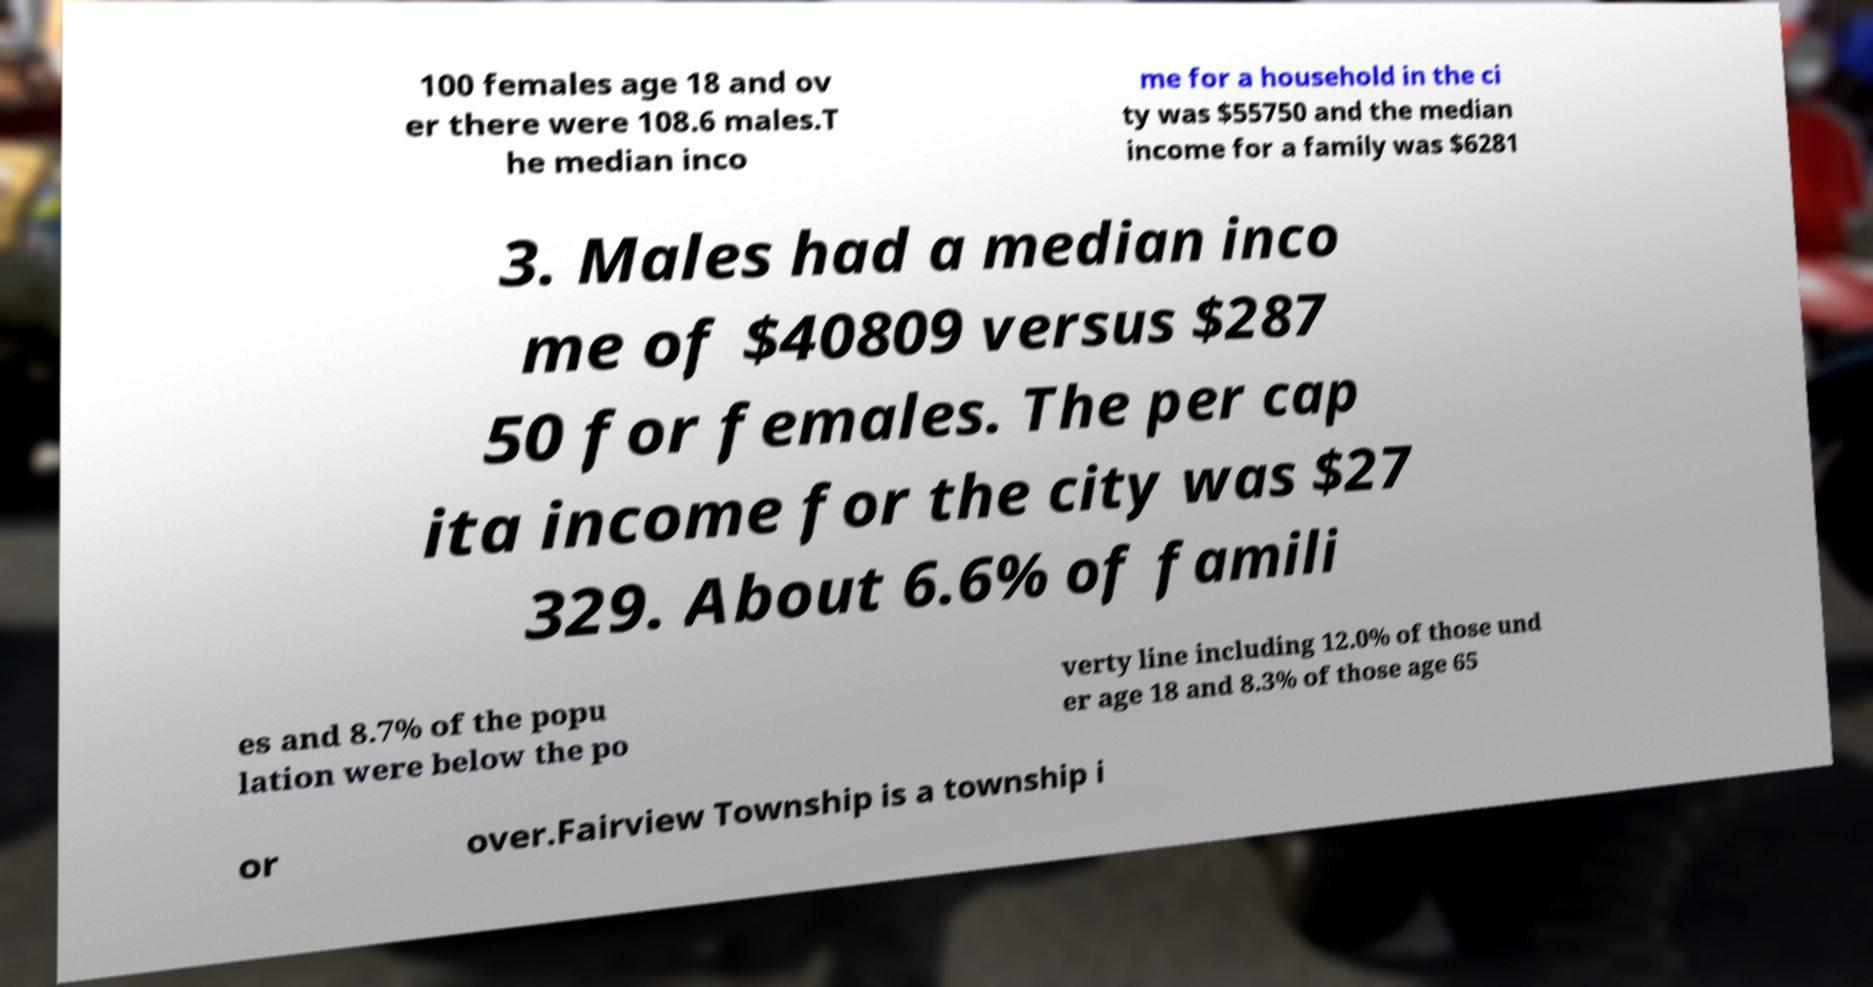There's text embedded in this image that I need extracted. Can you transcribe it verbatim? 100 females age 18 and ov er there were 108.6 males.T he median inco me for a household in the ci ty was $55750 and the median income for a family was $6281 3. Males had a median inco me of $40809 versus $287 50 for females. The per cap ita income for the city was $27 329. About 6.6% of famili es and 8.7% of the popu lation were below the po verty line including 12.0% of those und er age 18 and 8.3% of those age 65 or over.Fairview Township is a township i 